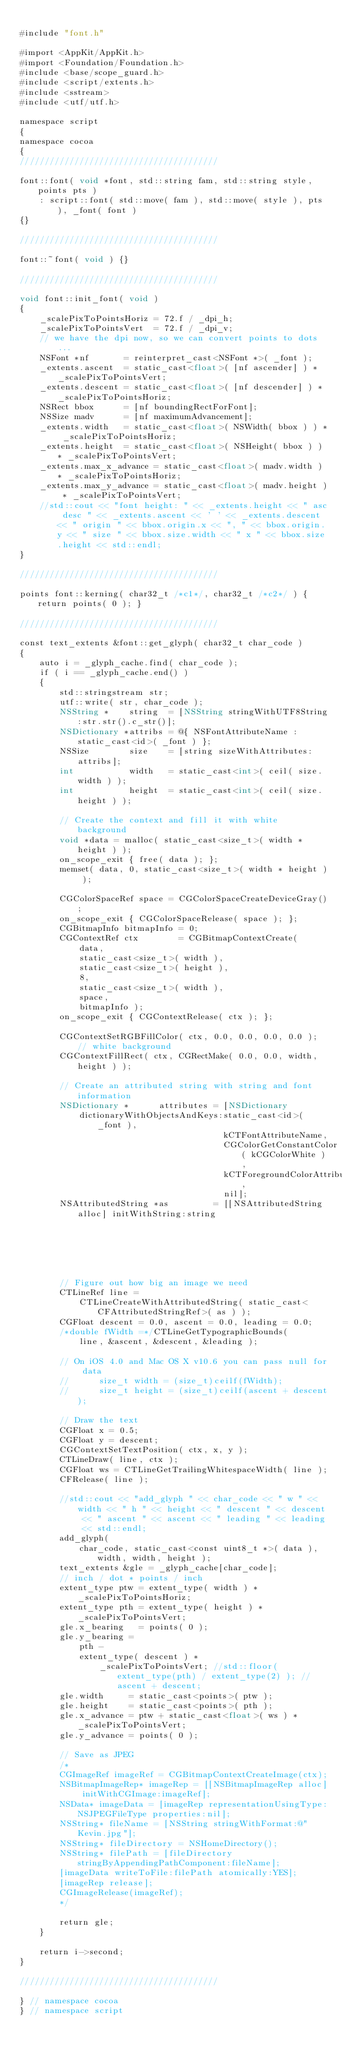<code> <loc_0><loc_0><loc_500><loc_500><_ObjectiveC_>
#include "font.h"

#import <AppKit/AppKit.h>
#import <Foundation/Foundation.h>
#include <base/scope_guard.h>
#include <script/extents.h>
#include <sstream>
#include <utf/utf.h>

namespace script
{
namespace cocoa
{
////////////////////////////////////////

font::font( void *font, std::string fam, std::string style, points pts )
    : script::font( std::move( fam ), std::move( style ), pts ), _font( font )
{}

////////////////////////////////////////

font::~font( void ) {}

////////////////////////////////////////

void font::init_font( void )
{
    _scalePixToPointsHoriz = 72.f / _dpi_h;
    _scalePixToPointsVert  = 72.f / _dpi_v;
    // we have the dpi now, so we can convert points to dots...
    NSFont *nf       = reinterpret_cast<NSFont *>( _font );
    _extents.ascent  = static_cast<float>( [nf ascender] ) * _scalePixToPointsVert;
    _extents.descent = static_cast<float>( [nf descender] ) * _scalePixToPointsHoriz;
    NSRect bbox      = [nf boundingRectForFont];
    NSSize madv      = [nf maximumAdvancement];
    _extents.width   = static_cast<float>( NSWidth( bbox ) ) * _scalePixToPointsHoriz;
    _extents.height  = static_cast<float>( NSHeight( bbox ) ) * _scalePixToPointsVert;
    _extents.max_x_advance = static_cast<float>( madv.width ) * _scalePixToPointsHoriz;
    _extents.max_y_advance = static_cast<float>( madv.height ) * _scalePixToPointsVert;
    //std::cout << "font height: " << _extents.height << " asc desc " << _extents.ascent << ' ' << _extents.descent << " origin " << bbox.origin.x << ", " << bbox.origin.y << " size " << bbox.size.width << " x " << bbox.size.height << std::endl;
}

////////////////////////////////////////

points font::kerning( char32_t /*c1*/, char32_t /*c2*/ ) { return points( 0 ); }

////////////////////////////////////////

const text_extents &font::get_glyph( char32_t char_code )
{
    auto i = _glyph_cache.find( char_code );
    if ( i == _glyph_cache.end() )
    {
        std::stringstream str;
        utf::write( str, char_code );
        NSString *    string  = [NSString stringWithUTF8String:str.str().c_str()];
        NSDictionary *attribs = @{ NSFontAttributeName : static_cast<id>( _font ) };
        NSSize        size    = [string sizeWithAttributes:attribs];
        int           width   = static_cast<int>( ceil( size.width ) );
        int           height  = static_cast<int>( ceil( size.height ) );

        // Create the context and fill it with white background
        void *data = malloc( static_cast<size_t>( width * height ) );
        on_scope_exit { free( data ); };
        memset( data, 0, static_cast<size_t>( width * height ) );

        CGColorSpaceRef space = CGColorSpaceCreateDeviceGray();
        on_scope_exit { CGColorSpaceRelease( space ); };
        CGBitmapInfo bitmapInfo = 0;
        CGContextRef ctx        = CGBitmapContextCreate(
            data,
            static_cast<size_t>( width ),
            static_cast<size_t>( height ),
            8,
            static_cast<size_t>( width ),
            space,
            bitmapInfo );
        on_scope_exit { CGContextRelease( ctx ); };

        CGContextSetRGBFillColor( ctx, 0.0, 0.0, 0.0, 0.0 ); // white background
        CGContextFillRect( ctx, CGRectMake( 0.0, 0.0, width, height ) );

        // Create an attributed string with string and font information
        NSDictionary *      attributes = [NSDictionary
            dictionaryWithObjectsAndKeys:static_cast<id>( _font ),
                                         kCTFontAttributeName,
                                         CGColorGetConstantColor( kCGColorWhite ),
                                         kCTForegroundColorAttributeName,
                                         nil];
        NSAttributedString *as         = [[NSAttributedString alloc] initWithString:string
                                                                 attributes:attributes];

        // Figure out how big an image we need
        CTLineRef line =
            CTLineCreateWithAttributedString( static_cast<CFAttributedStringRef>( as ) );
        CGFloat descent = 0.0, ascent = 0.0, leading = 0.0;
        /*double fWidth =*/CTLineGetTypographicBounds(
            line, &ascent, &descent, &leading );

        // On iOS 4.0 and Mac OS X v10.6 you can pass null for data
        //		size_t width = (size_t)ceilf(fWidth);
        //		size_t height = (size_t)ceilf(ascent + descent);

        // Draw the text
        CGFloat x = 0.5;
        CGFloat y = descent;
        CGContextSetTextPosition( ctx, x, y );
        CTLineDraw( line, ctx );
        CGFloat ws = CTLineGetTrailingWhitespaceWidth( line );
        CFRelease( line );

        //std::cout << "add_glyph " << char_code << " w " << width << " h " << height << " descent " << descent << " ascent " << ascent << " leading " << leading << std::endl;
        add_glyph(
            char_code, static_cast<const uint8_t *>( data ), width, width, height );
        text_extents &gle = _glyph_cache[char_code];
        // inch / dot * points / inch
        extent_type ptw = extent_type( width ) * _scalePixToPointsHoriz;
        extent_type pth = extent_type( height ) * _scalePixToPointsVert;
        gle.x_bearing   = points( 0 );
        gle.y_bearing =
            pth -
            extent_type( descent ) *
                _scalePixToPointsVert; //std::floor( extent_type(pth) / extent_type(2) ); //ascent + descent;
        gle.width     = static_cast<points>( ptw );
        gle.height    = static_cast<points>( pth );
        gle.x_advance = ptw + static_cast<float>( ws ) * _scalePixToPointsVert;
        gle.y_advance = points( 0 );

        // Save as JPEG
        /*
        CGImageRef imageRef = CGBitmapContextCreateImage(ctx);
        NSBitmapImageRep* imageRep = [[NSBitmapImageRep alloc] initWithCGImage:imageRef];
        NSData* imageData = [imageRep representationUsingType:NSJPEGFileType properties:nil];
        NSString* fileName = [NSString stringWithFormat:@"Kevin.jpg"];
        NSString* fileDirectory = NSHomeDirectory();
        NSString* filePath = [fileDirectory stringByAppendingPathComponent:fileName];
        [imageData writeToFile:filePath atomically:YES];
        [imageRep release];
        CGImageRelease(imageRef);
        */

        return gle;
    }

    return i->second;
}

////////////////////////////////////////

} // namespace cocoa
} // namespace script
</code> 